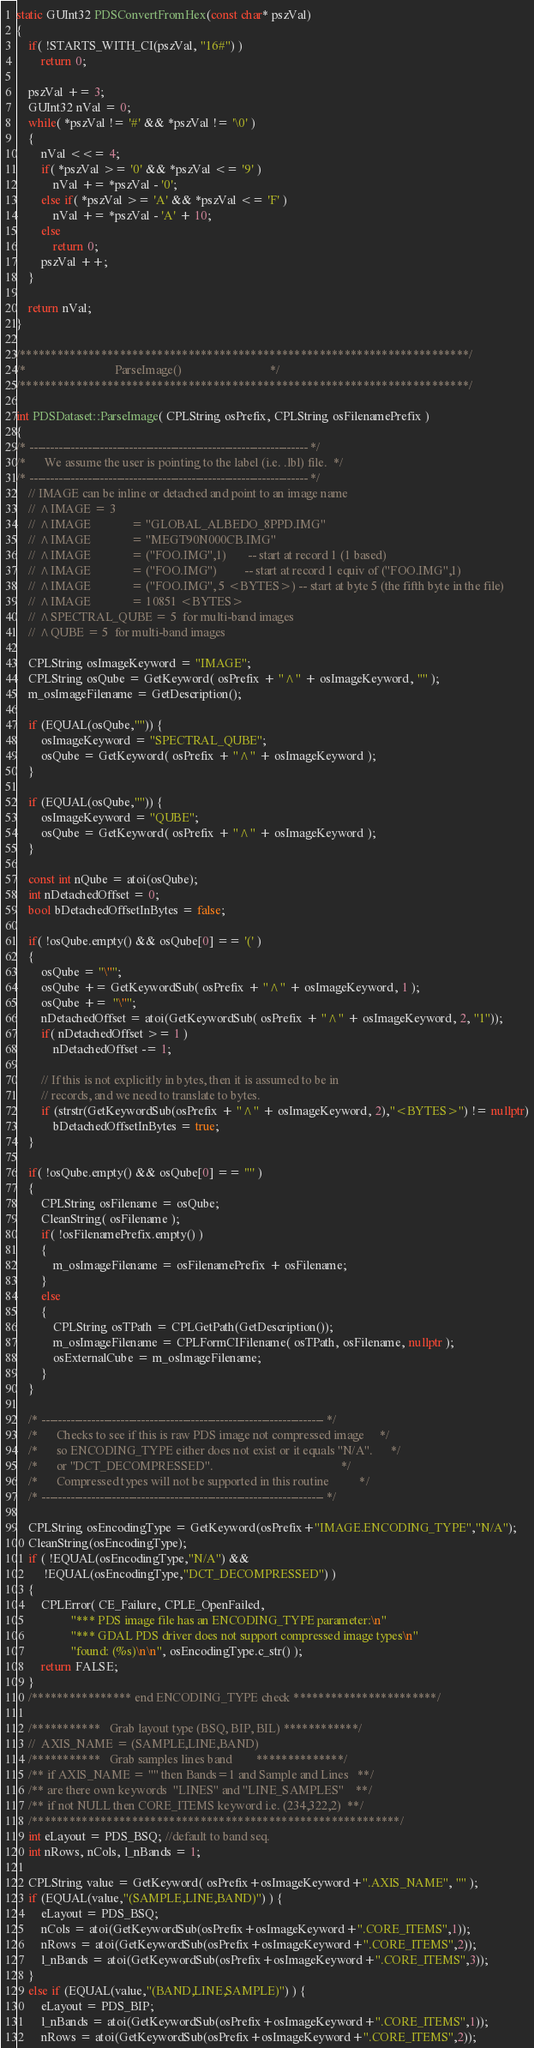<code> <loc_0><loc_0><loc_500><loc_500><_C++_>
static GUInt32 PDSConvertFromHex(const char* pszVal)
{
    if( !STARTS_WITH_CI(pszVal, "16#") )
        return 0;

    pszVal += 3;
    GUInt32 nVal = 0;
    while( *pszVal != '#' && *pszVal != '\0' )
    {
        nVal <<= 4;
        if( *pszVal >= '0' && *pszVal <= '9' )
            nVal += *pszVal - '0';
        else if( *pszVal >= 'A' && *pszVal <= 'F' )
            nVal += *pszVal - 'A' + 10;
        else
            return 0;
        pszVal ++;
    }

    return nVal;
}

/************************************************************************/
/*                             ParseImage()                             */
/************************************************************************/

int PDSDataset::ParseImage( CPLString osPrefix, CPLString osFilenamePrefix )
{
/* ------------------------------------------------------------------- */
/*      We assume the user is pointing to the label (i.e. .lbl) file.  */
/* ------------------------------------------------------------------- */
    // IMAGE can be inline or detached and point to an image name
    // ^IMAGE = 3
    // ^IMAGE             = "GLOBAL_ALBEDO_8PPD.IMG"
    // ^IMAGE             = "MEGT90N000CB.IMG"
    // ^IMAGE             = ("FOO.IMG",1)       -- start at record 1 (1 based)
    // ^IMAGE             = ("FOO.IMG")         -- start at record 1 equiv of ("FOO.IMG",1)
    // ^IMAGE             = ("FOO.IMG", 5 <BYTES>) -- start at byte 5 (the fifth byte in the file)
    // ^IMAGE             = 10851 <BYTES>
    // ^SPECTRAL_QUBE = 5  for multi-band images
    // ^QUBE = 5  for multi-band images

    CPLString osImageKeyword = "IMAGE";
    CPLString osQube = GetKeyword( osPrefix + "^" + osImageKeyword, "" );
    m_osImageFilename = GetDescription();

    if (EQUAL(osQube,"")) {
        osImageKeyword = "SPECTRAL_QUBE";
        osQube = GetKeyword( osPrefix + "^" + osImageKeyword );
    }

    if (EQUAL(osQube,"")) {
        osImageKeyword = "QUBE";
        osQube = GetKeyword( osPrefix + "^" + osImageKeyword );
    }

    const int nQube = atoi(osQube);
    int nDetachedOffset = 0;
    bool bDetachedOffsetInBytes = false;

    if( !osQube.empty() && osQube[0] == '(' )
    {
        osQube = "\"";
        osQube += GetKeywordSub( osPrefix + "^" + osImageKeyword, 1 );
        osQube +=  "\"";
        nDetachedOffset = atoi(GetKeywordSub( osPrefix + "^" + osImageKeyword, 2, "1"));
        if( nDetachedOffset >= 1 )
            nDetachedOffset -= 1;

        // If this is not explicitly in bytes, then it is assumed to be in
        // records, and we need to translate to bytes.
        if (strstr(GetKeywordSub(osPrefix + "^" + osImageKeyword, 2),"<BYTES>") != nullptr)
            bDetachedOffsetInBytes = true;
    }

    if( !osQube.empty() && osQube[0] == '"' )
    {
        CPLString osFilename = osQube;
        CleanString( osFilename );
        if( !osFilenamePrefix.empty() )
        {
            m_osImageFilename = osFilenamePrefix + osFilename;
        }
        else
        {
            CPLString osTPath = CPLGetPath(GetDescription());
            m_osImageFilename = CPLFormCIFilename( osTPath, osFilename, nullptr );
            osExternalCube = m_osImageFilename;
        }
    }

    /* -------------------------------------------------------------------- */
    /*      Checks to see if this is raw PDS image not compressed image     */
    /*      so ENCODING_TYPE either does not exist or it equals "N/A".      */
    /*      or "DCT_DECOMPRESSED".                                          */
    /*      Compressed types will not be supported in this routine          */
    /* -------------------------------------------------------------------- */

    CPLString osEncodingType = GetKeyword(osPrefix+"IMAGE.ENCODING_TYPE","N/A");
    CleanString(osEncodingType);
    if ( !EQUAL(osEncodingType,"N/A") &&
         !EQUAL(osEncodingType,"DCT_DECOMPRESSED") )
    {
        CPLError( CE_Failure, CPLE_OpenFailed,
                  "*** PDS image file has an ENCODING_TYPE parameter:\n"
                  "*** GDAL PDS driver does not support compressed image types\n"
                  "found: (%s)\n\n", osEncodingType.c_str() );
        return FALSE;
    }
    /**************** end ENCODING_TYPE check ***********************/

    /***********   Grab layout type (BSQ, BIP, BIL) ************/
    //  AXIS_NAME = (SAMPLE,LINE,BAND)
    /***********   Grab samples lines band        **************/
    /** if AXIS_NAME = "" then Bands=1 and Sample and Lines   **/
    /** are there own keywords  "LINES" and "LINE_SAMPLES"    **/
    /** if not NULL then CORE_ITEMS keyword i.e. (234,322,2)  **/
    /***********************************************************/
    int eLayout = PDS_BSQ; //default to band seq.
    int nRows, nCols, l_nBands = 1;

    CPLString value = GetKeyword( osPrefix+osImageKeyword+".AXIS_NAME", "" );
    if (EQUAL(value,"(SAMPLE,LINE,BAND)") ) {
        eLayout = PDS_BSQ;
        nCols = atoi(GetKeywordSub(osPrefix+osImageKeyword+".CORE_ITEMS",1));
        nRows = atoi(GetKeywordSub(osPrefix+osImageKeyword+".CORE_ITEMS",2));
        l_nBands = atoi(GetKeywordSub(osPrefix+osImageKeyword+".CORE_ITEMS",3));
    }
    else if (EQUAL(value,"(BAND,LINE,SAMPLE)") ) {
        eLayout = PDS_BIP;
        l_nBands = atoi(GetKeywordSub(osPrefix+osImageKeyword+".CORE_ITEMS",1));
        nRows = atoi(GetKeywordSub(osPrefix+osImageKeyword+".CORE_ITEMS",2));</code> 